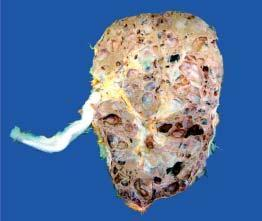s the kidney enlarged and heavy?
Answer the question using a single word or phrase. Yes 